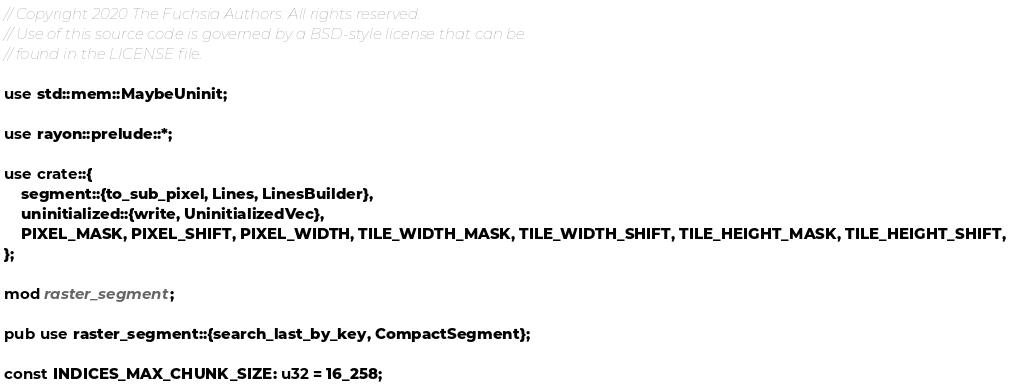Convert code to text. <code><loc_0><loc_0><loc_500><loc_500><_Rust_>// Copyright 2020 The Fuchsia Authors. All rights reserved.
// Use of this source code is governed by a BSD-style license that can be
// found in the LICENSE file.

use std::mem::MaybeUninit;

use rayon::prelude::*;

use crate::{
    segment::{to_sub_pixel, Lines, LinesBuilder},
    uninitialized::{write, UninitializedVec},
    PIXEL_MASK, PIXEL_SHIFT, PIXEL_WIDTH, TILE_WIDTH_MASK, TILE_WIDTH_SHIFT, TILE_HEIGHT_MASK, TILE_HEIGHT_SHIFT,
};

mod raster_segment;

pub use raster_segment::{search_last_by_key, CompactSegment};

const INDICES_MAX_CHUNK_SIZE: u32 = 16_258;</code> 